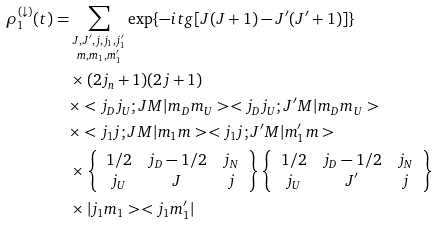<formula> <loc_0><loc_0><loc_500><loc_500>\rho _ { 1 } ^ { ( \downarrow ) } ( t ) & = \sum _ { \substack { J , J ^ { \prime } , j , j _ { 1 } , j ^ { \prime } _ { 1 } \\ m , m _ { 1 } , m ^ { \prime } _ { 1 } } } \exp \{ - i t g [ J ( J + 1 ) - J ^ { \prime } ( J ^ { \prime } + 1 ) ] \} \\ & \quad \times ( 2 j _ { n } + 1 ) ( 2 j + 1 ) \\ & \quad \times < j _ { D } j _ { U } ; J M | m _ { D } m _ { U } > < j _ { D } j _ { U } ; J ^ { \prime } M | m _ { D } m _ { U } > \\ & \quad \times < j _ { 1 } j ; J M | m _ { 1 } m > < j _ { 1 } j ; J ^ { \prime } M | m ^ { \prime } _ { 1 } m > \\ & \quad \times \left \{ \begin{array} { c c c } 1 / 2 & j _ { D } - 1 / 2 & j _ { N } \\ j _ { U } & J & j \end{array} \right \} \left \{ \begin{array} { c c c } 1 / 2 & j _ { D } - 1 / 2 & j _ { N } \\ j _ { U } & J ^ { \prime } & j \end{array} \right \} \\ & \quad \times | j _ { 1 } m _ { 1 } > < j _ { 1 } m ^ { \prime } _ { 1 } |</formula> 